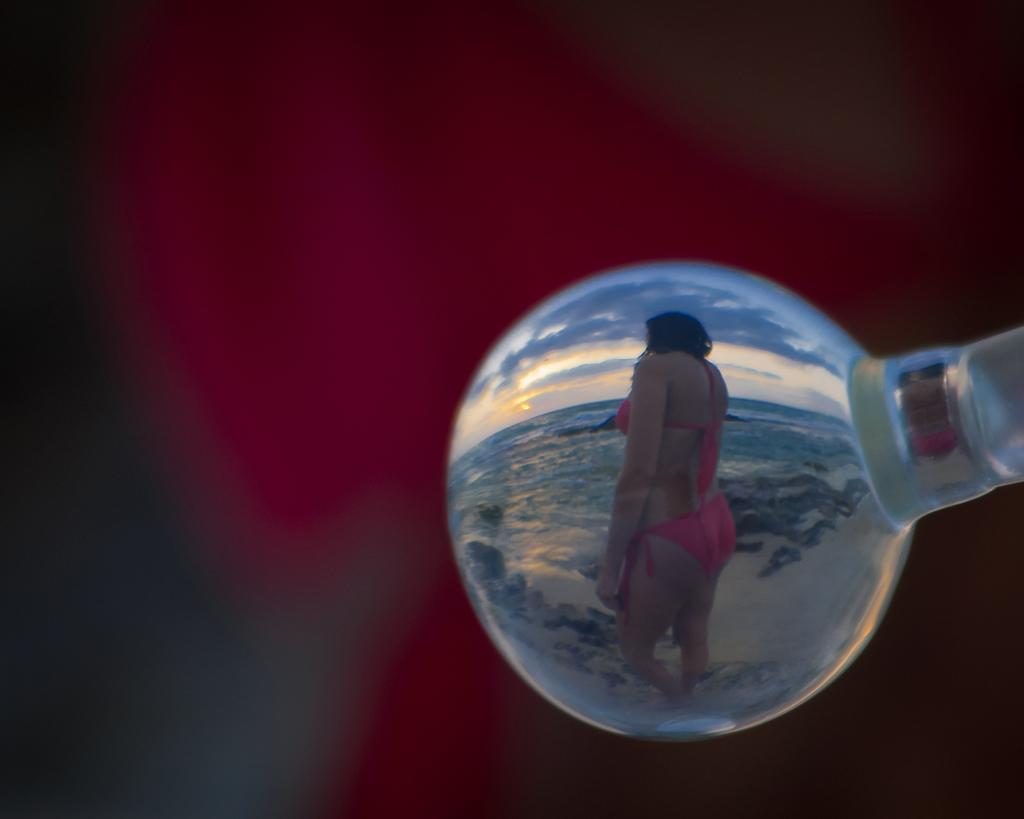What is the color of the object in the image? The object in the image is white. Who or what is inside the object? A person is inside the object. What can be seen inside the object besides the person? There is water visible inside the object. How would you describe the sky in the image? The sky is blue and white. Can you describe the background of the image? The background of the image is blurred. How many ladybugs are crawling on the person's arm in the image? There are no ladybugs visible in the image. What type of food is the person cooking inside the object? There is no cooking or food preparation happening inside the object in the image. 